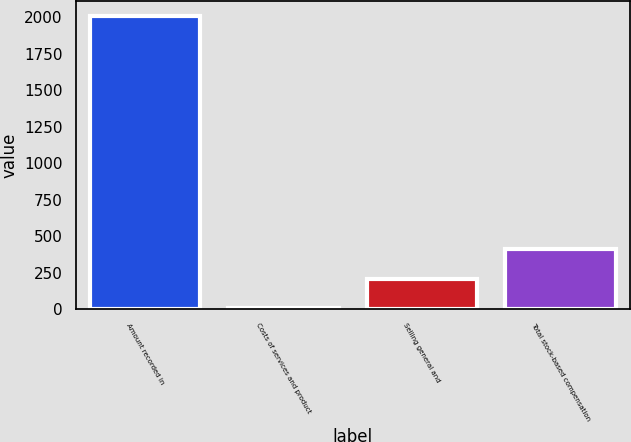<chart> <loc_0><loc_0><loc_500><loc_500><bar_chart><fcel>Amount recorded in<fcel>Costs of services and product<fcel>Selling general and<fcel>Total stock-based compensation<nl><fcel>2008<fcel>9.6<fcel>209.44<fcel>409.28<nl></chart> 